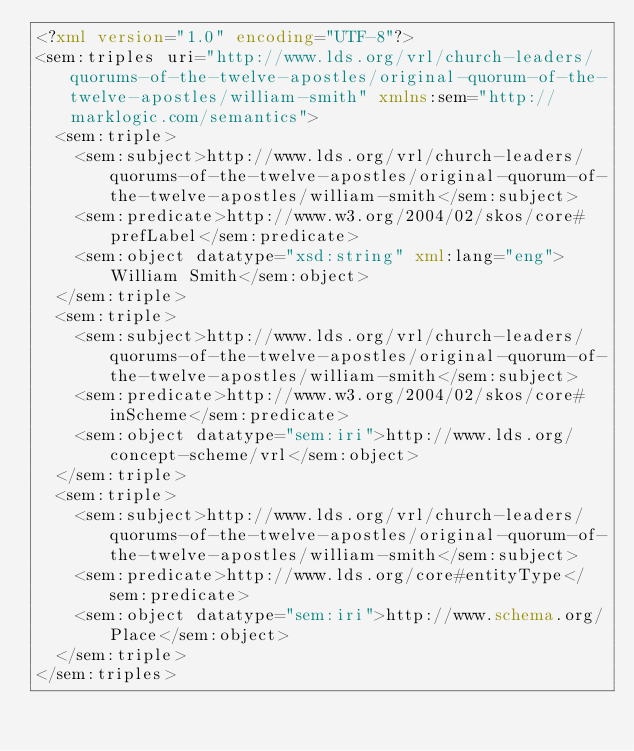Convert code to text. <code><loc_0><loc_0><loc_500><loc_500><_XML_><?xml version="1.0" encoding="UTF-8"?>
<sem:triples uri="http://www.lds.org/vrl/church-leaders/quorums-of-the-twelve-apostles/original-quorum-of-the-twelve-apostles/william-smith" xmlns:sem="http://marklogic.com/semantics">
  <sem:triple>
    <sem:subject>http://www.lds.org/vrl/church-leaders/quorums-of-the-twelve-apostles/original-quorum-of-the-twelve-apostles/william-smith</sem:subject>
    <sem:predicate>http://www.w3.org/2004/02/skos/core#prefLabel</sem:predicate>
    <sem:object datatype="xsd:string" xml:lang="eng">William Smith</sem:object>
  </sem:triple>
  <sem:triple>
    <sem:subject>http://www.lds.org/vrl/church-leaders/quorums-of-the-twelve-apostles/original-quorum-of-the-twelve-apostles/william-smith</sem:subject>
    <sem:predicate>http://www.w3.org/2004/02/skos/core#inScheme</sem:predicate>
    <sem:object datatype="sem:iri">http://www.lds.org/concept-scheme/vrl</sem:object>
  </sem:triple>
  <sem:triple>
    <sem:subject>http://www.lds.org/vrl/church-leaders/quorums-of-the-twelve-apostles/original-quorum-of-the-twelve-apostles/william-smith</sem:subject>
    <sem:predicate>http://www.lds.org/core#entityType</sem:predicate>
    <sem:object datatype="sem:iri">http://www.schema.org/Place</sem:object>
  </sem:triple>
</sem:triples>
</code> 